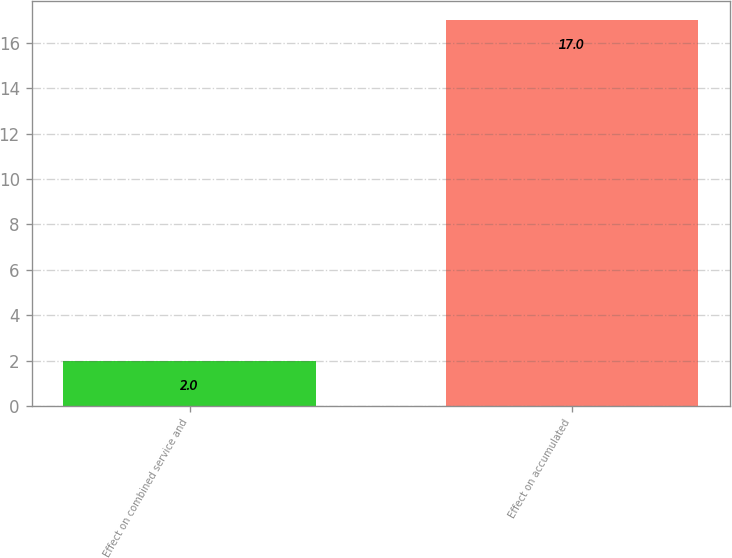Convert chart to OTSL. <chart><loc_0><loc_0><loc_500><loc_500><bar_chart><fcel>Effect on combined service and<fcel>Effect on accumulated<nl><fcel>2<fcel>17<nl></chart> 